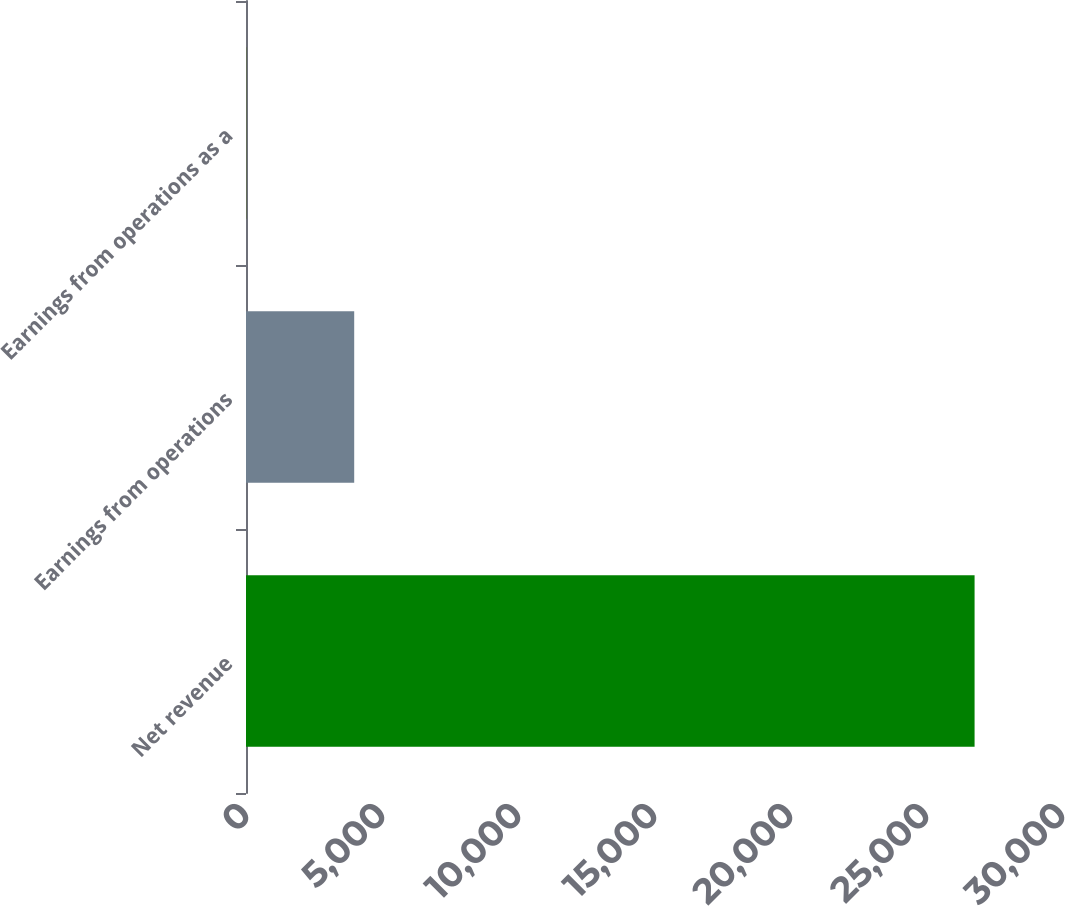Convert chart to OTSL. <chart><loc_0><loc_0><loc_500><loc_500><bar_chart><fcel>Net revenue<fcel>Earnings from operations<fcel>Earnings from operations as a<nl><fcel>26786<fcel>3978<fcel>14.9<nl></chart> 